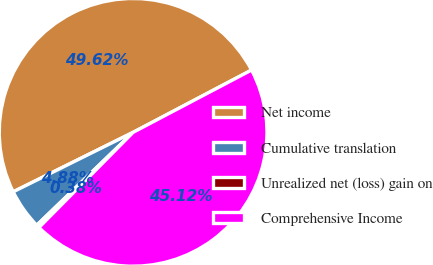<chart> <loc_0><loc_0><loc_500><loc_500><pie_chart><fcel>Net income<fcel>Cumulative translation<fcel>Unrealized net (loss) gain on<fcel>Comprehensive Income<nl><fcel>49.62%<fcel>4.88%<fcel>0.38%<fcel>45.12%<nl></chart> 